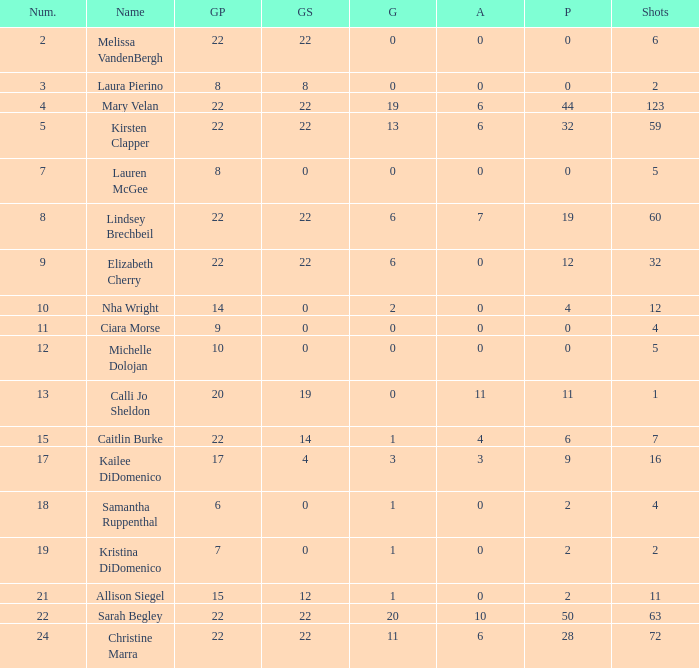How many games played catagories are there for Lauren McGee?  1.0. 